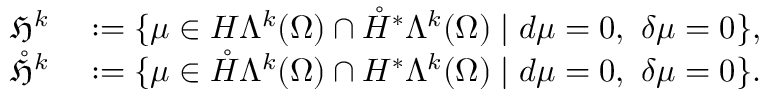<formula> <loc_0><loc_0><loc_500><loc_500>\begin{array} { r l } { \mathfrak { H } ^ { k } } & \colon = \{ \mu \in H \Lambda ^ { k } ( \Omega ) \cap \mathring { H } ^ { \ast } \Lambda ^ { k } ( { \Omega } ) | d \mu = 0 , \ \delta \mu = 0 \} , } \\ { \mathring { \mathfrak { H } } ^ { k } } & \colon = \{ \mu \in \mathring { H } \Lambda ^ { k } ( \Omega ) \cap H ^ { \ast } \Lambda ^ { k } ( { \Omega } ) | d \mu = 0 , \ \delta \mu = 0 \} . } \end{array}</formula> 